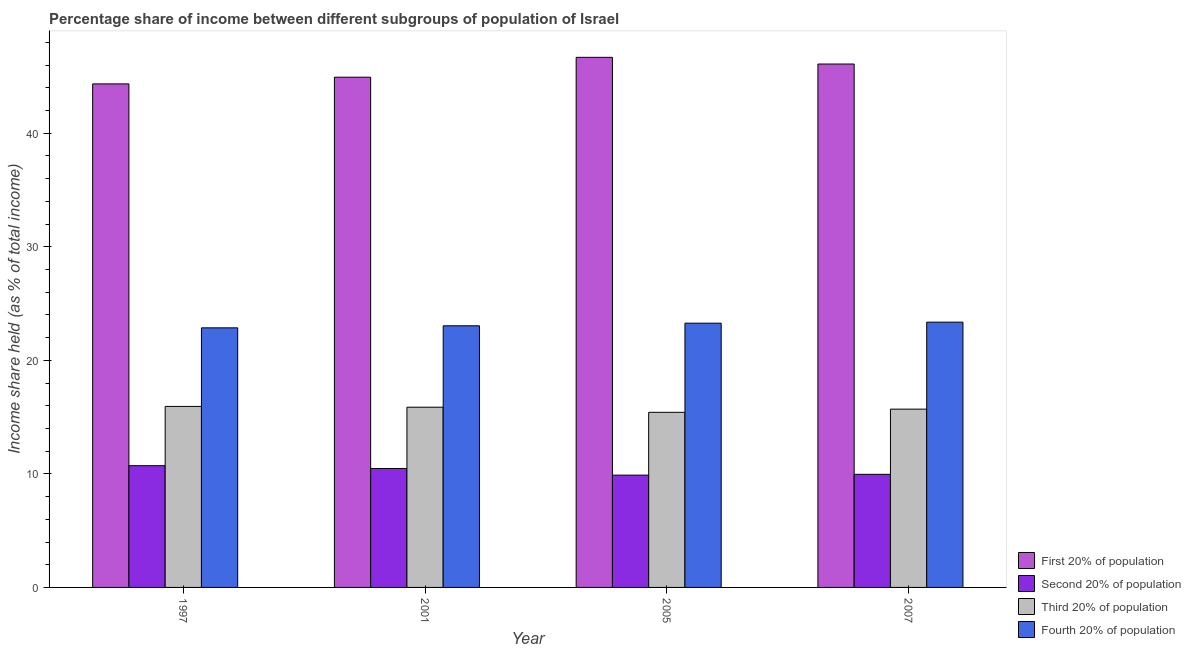How many different coloured bars are there?
Your response must be concise. 4. How many groups of bars are there?
Offer a very short reply. 4. Are the number of bars on each tick of the X-axis equal?
Provide a short and direct response. Yes. How many bars are there on the 3rd tick from the left?
Provide a short and direct response. 4. What is the label of the 3rd group of bars from the left?
Offer a very short reply. 2005. In how many cases, is the number of bars for a given year not equal to the number of legend labels?
Keep it short and to the point. 0. What is the share of the income held by third 20% of the population in 2007?
Your answer should be compact. 15.7. Across all years, what is the maximum share of the income held by third 20% of the population?
Your answer should be compact. 15.94. Across all years, what is the minimum share of the income held by fourth 20% of the population?
Offer a terse response. 22.86. In which year was the share of the income held by second 20% of the population maximum?
Keep it short and to the point. 1997. What is the total share of the income held by third 20% of the population in the graph?
Give a very brief answer. 62.93. What is the difference between the share of the income held by second 20% of the population in 1997 and that in 2005?
Provide a short and direct response. 0.83. What is the difference between the share of the income held by first 20% of the population in 2005 and the share of the income held by third 20% of the population in 2007?
Your answer should be very brief. 0.59. What is the average share of the income held by first 20% of the population per year?
Keep it short and to the point. 45.51. In the year 2007, what is the difference between the share of the income held by fourth 20% of the population and share of the income held by first 20% of the population?
Offer a terse response. 0. What is the ratio of the share of the income held by first 20% of the population in 1997 to that in 2001?
Provide a succinct answer. 0.99. Is the share of the income held by second 20% of the population in 1997 less than that in 2001?
Your response must be concise. No. Is the difference between the share of the income held by first 20% of the population in 1997 and 2001 greater than the difference between the share of the income held by fourth 20% of the population in 1997 and 2001?
Your response must be concise. No. What is the difference between the highest and the second highest share of the income held by first 20% of the population?
Offer a terse response. 0.59. What is the difference between the highest and the lowest share of the income held by first 20% of the population?
Keep it short and to the point. 2.34. Is the sum of the share of the income held by third 20% of the population in 1997 and 2007 greater than the maximum share of the income held by fourth 20% of the population across all years?
Offer a terse response. Yes. What does the 4th bar from the left in 1997 represents?
Your answer should be very brief. Fourth 20% of population. What does the 3rd bar from the right in 1997 represents?
Make the answer very short. Second 20% of population. Is it the case that in every year, the sum of the share of the income held by first 20% of the population and share of the income held by second 20% of the population is greater than the share of the income held by third 20% of the population?
Offer a terse response. Yes. What is the difference between two consecutive major ticks on the Y-axis?
Provide a short and direct response. 10. Are the values on the major ticks of Y-axis written in scientific E-notation?
Your answer should be compact. No. Does the graph contain any zero values?
Your answer should be compact. No. Where does the legend appear in the graph?
Your response must be concise. Bottom right. How are the legend labels stacked?
Provide a succinct answer. Vertical. What is the title of the graph?
Your answer should be very brief. Percentage share of income between different subgroups of population of Israel. Does "Norway" appear as one of the legend labels in the graph?
Make the answer very short. No. What is the label or title of the Y-axis?
Offer a terse response. Income share held (as % of total income). What is the Income share held (as % of total income) of First 20% of population in 1997?
Your response must be concise. 44.34. What is the Income share held (as % of total income) in Second 20% of population in 1997?
Give a very brief answer. 10.72. What is the Income share held (as % of total income) of Third 20% of population in 1997?
Your answer should be very brief. 15.94. What is the Income share held (as % of total income) in Fourth 20% of population in 1997?
Give a very brief answer. 22.86. What is the Income share held (as % of total income) in First 20% of population in 2001?
Make the answer very short. 44.93. What is the Income share held (as % of total income) of Second 20% of population in 2001?
Your response must be concise. 10.47. What is the Income share held (as % of total income) of Third 20% of population in 2001?
Give a very brief answer. 15.87. What is the Income share held (as % of total income) of Fourth 20% of population in 2001?
Provide a succinct answer. 23.04. What is the Income share held (as % of total income) of First 20% of population in 2005?
Provide a short and direct response. 46.68. What is the Income share held (as % of total income) in Second 20% of population in 2005?
Offer a terse response. 9.89. What is the Income share held (as % of total income) in Third 20% of population in 2005?
Give a very brief answer. 15.42. What is the Income share held (as % of total income) in Fourth 20% of population in 2005?
Offer a terse response. 23.27. What is the Income share held (as % of total income) in First 20% of population in 2007?
Make the answer very short. 46.09. What is the Income share held (as % of total income) of Second 20% of population in 2007?
Give a very brief answer. 9.96. What is the Income share held (as % of total income) in Third 20% of population in 2007?
Keep it short and to the point. 15.7. What is the Income share held (as % of total income) in Fourth 20% of population in 2007?
Provide a short and direct response. 23.36. Across all years, what is the maximum Income share held (as % of total income) of First 20% of population?
Your response must be concise. 46.68. Across all years, what is the maximum Income share held (as % of total income) in Second 20% of population?
Offer a terse response. 10.72. Across all years, what is the maximum Income share held (as % of total income) of Third 20% of population?
Offer a very short reply. 15.94. Across all years, what is the maximum Income share held (as % of total income) in Fourth 20% of population?
Your answer should be compact. 23.36. Across all years, what is the minimum Income share held (as % of total income) in First 20% of population?
Your response must be concise. 44.34. Across all years, what is the minimum Income share held (as % of total income) in Second 20% of population?
Ensure brevity in your answer.  9.89. Across all years, what is the minimum Income share held (as % of total income) in Third 20% of population?
Your answer should be very brief. 15.42. Across all years, what is the minimum Income share held (as % of total income) in Fourth 20% of population?
Ensure brevity in your answer.  22.86. What is the total Income share held (as % of total income) of First 20% of population in the graph?
Offer a very short reply. 182.04. What is the total Income share held (as % of total income) of Second 20% of population in the graph?
Ensure brevity in your answer.  41.04. What is the total Income share held (as % of total income) in Third 20% of population in the graph?
Keep it short and to the point. 62.93. What is the total Income share held (as % of total income) in Fourth 20% of population in the graph?
Keep it short and to the point. 92.53. What is the difference between the Income share held (as % of total income) of First 20% of population in 1997 and that in 2001?
Ensure brevity in your answer.  -0.59. What is the difference between the Income share held (as % of total income) in Third 20% of population in 1997 and that in 2001?
Your answer should be compact. 0.07. What is the difference between the Income share held (as % of total income) of Fourth 20% of population in 1997 and that in 2001?
Offer a very short reply. -0.18. What is the difference between the Income share held (as % of total income) in First 20% of population in 1997 and that in 2005?
Your answer should be compact. -2.34. What is the difference between the Income share held (as % of total income) of Second 20% of population in 1997 and that in 2005?
Your answer should be compact. 0.83. What is the difference between the Income share held (as % of total income) of Third 20% of population in 1997 and that in 2005?
Your answer should be very brief. 0.52. What is the difference between the Income share held (as % of total income) of Fourth 20% of population in 1997 and that in 2005?
Keep it short and to the point. -0.41. What is the difference between the Income share held (as % of total income) of First 20% of population in 1997 and that in 2007?
Ensure brevity in your answer.  -1.75. What is the difference between the Income share held (as % of total income) of Second 20% of population in 1997 and that in 2007?
Your answer should be very brief. 0.76. What is the difference between the Income share held (as % of total income) in Third 20% of population in 1997 and that in 2007?
Provide a succinct answer. 0.24. What is the difference between the Income share held (as % of total income) of First 20% of population in 2001 and that in 2005?
Provide a short and direct response. -1.75. What is the difference between the Income share held (as % of total income) of Second 20% of population in 2001 and that in 2005?
Provide a short and direct response. 0.58. What is the difference between the Income share held (as % of total income) in Third 20% of population in 2001 and that in 2005?
Provide a succinct answer. 0.45. What is the difference between the Income share held (as % of total income) in Fourth 20% of population in 2001 and that in 2005?
Your response must be concise. -0.23. What is the difference between the Income share held (as % of total income) of First 20% of population in 2001 and that in 2007?
Keep it short and to the point. -1.16. What is the difference between the Income share held (as % of total income) in Second 20% of population in 2001 and that in 2007?
Your answer should be compact. 0.51. What is the difference between the Income share held (as % of total income) of Third 20% of population in 2001 and that in 2007?
Make the answer very short. 0.17. What is the difference between the Income share held (as % of total income) in Fourth 20% of population in 2001 and that in 2007?
Your answer should be compact. -0.32. What is the difference between the Income share held (as % of total income) in First 20% of population in 2005 and that in 2007?
Your answer should be compact. 0.59. What is the difference between the Income share held (as % of total income) in Second 20% of population in 2005 and that in 2007?
Ensure brevity in your answer.  -0.07. What is the difference between the Income share held (as % of total income) of Third 20% of population in 2005 and that in 2007?
Your answer should be compact. -0.28. What is the difference between the Income share held (as % of total income) in Fourth 20% of population in 2005 and that in 2007?
Your answer should be very brief. -0.09. What is the difference between the Income share held (as % of total income) of First 20% of population in 1997 and the Income share held (as % of total income) of Second 20% of population in 2001?
Your response must be concise. 33.87. What is the difference between the Income share held (as % of total income) of First 20% of population in 1997 and the Income share held (as % of total income) of Third 20% of population in 2001?
Offer a very short reply. 28.47. What is the difference between the Income share held (as % of total income) of First 20% of population in 1997 and the Income share held (as % of total income) of Fourth 20% of population in 2001?
Offer a very short reply. 21.3. What is the difference between the Income share held (as % of total income) of Second 20% of population in 1997 and the Income share held (as % of total income) of Third 20% of population in 2001?
Offer a terse response. -5.15. What is the difference between the Income share held (as % of total income) in Second 20% of population in 1997 and the Income share held (as % of total income) in Fourth 20% of population in 2001?
Your response must be concise. -12.32. What is the difference between the Income share held (as % of total income) of First 20% of population in 1997 and the Income share held (as % of total income) of Second 20% of population in 2005?
Give a very brief answer. 34.45. What is the difference between the Income share held (as % of total income) in First 20% of population in 1997 and the Income share held (as % of total income) in Third 20% of population in 2005?
Ensure brevity in your answer.  28.92. What is the difference between the Income share held (as % of total income) in First 20% of population in 1997 and the Income share held (as % of total income) in Fourth 20% of population in 2005?
Make the answer very short. 21.07. What is the difference between the Income share held (as % of total income) in Second 20% of population in 1997 and the Income share held (as % of total income) in Third 20% of population in 2005?
Your answer should be compact. -4.7. What is the difference between the Income share held (as % of total income) in Second 20% of population in 1997 and the Income share held (as % of total income) in Fourth 20% of population in 2005?
Provide a short and direct response. -12.55. What is the difference between the Income share held (as % of total income) in Third 20% of population in 1997 and the Income share held (as % of total income) in Fourth 20% of population in 2005?
Keep it short and to the point. -7.33. What is the difference between the Income share held (as % of total income) in First 20% of population in 1997 and the Income share held (as % of total income) in Second 20% of population in 2007?
Keep it short and to the point. 34.38. What is the difference between the Income share held (as % of total income) in First 20% of population in 1997 and the Income share held (as % of total income) in Third 20% of population in 2007?
Provide a short and direct response. 28.64. What is the difference between the Income share held (as % of total income) of First 20% of population in 1997 and the Income share held (as % of total income) of Fourth 20% of population in 2007?
Provide a short and direct response. 20.98. What is the difference between the Income share held (as % of total income) in Second 20% of population in 1997 and the Income share held (as % of total income) in Third 20% of population in 2007?
Offer a very short reply. -4.98. What is the difference between the Income share held (as % of total income) of Second 20% of population in 1997 and the Income share held (as % of total income) of Fourth 20% of population in 2007?
Keep it short and to the point. -12.64. What is the difference between the Income share held (as % of total income) of Third 20% of population in 1997 and the Income share held (as % of total income) of Fourth 20% of population in 2007?
Provide a succinct answer. -7.42. What is the difference between the Income share held (as % of total income) in First 20% of population in 2001 and the Income share held (as % of total income) in Second 20% of population in 2005?
Offer a terse response. 35.04. What is the difference between the Income share held (as % of total income) of First 20% of population in 2001 and the Income share held (as % of total income) of Third 20% of population in 2005?
Your answer should be compact. 29.51. What is the difference between the Income share held (as % of total income) of First 20% of population in 2001 and the Income share held (as % of total income) of Fourth 20% of population in 2005?
Provide a short and direct response. 21.66. What is the difference between the Income share held (as % of total income) of Second 20% of population in 2001 and the Income share held (as % of total income) of Third 20% of population in 2005?
Ensure brevity in your answer.  -4.95. What is the difference between the Income share held (as % of total income) of First 20% of population in 2001 and the Income share held (as % of total income) of Second 20% of population in 2007?
Your answer should be compact. 34.97. What is the difference between the Income share held (as % of total income) in First 20% of population in 2001 and the Income share held (as % of total income) in Third 20% of population in 2007?
Provide a succinct answer. 29.23. What is the difference between the Income share held (as % of total income) in First 20% of population in 2001 and the Income share held (as % of total income) in Fourth 20% of population in 2007?
Make the answer very short. 21.57. What is the difference between the Income share held (as % of total income) of Second 20% of population in 2001 and the Income share held (as % of total income) of Third 20% of population in 2007?
Your answer should be very brief. -5.23. What is the difference between the Income share held (as % of total income) of Second 20% of population in 2001 and the Income share held (as % of total income) of Fourth 20% of population in 2007?
Make the answer very short. -12.89. What is the difference between the Income share held (as % of total income) in Third 20% of population in 2001 and the Income share held (as % of total income) in Fourth 20% of population in 2007?
Provide a succinct answer. -7.49. What is the difference between the Income share held (as % of total income) in First 20% of population in 2005 and the Income share held (as % of total income) in Second 20% of population in 2007?
Your answer should be very brief. 36.72. What is the difference between the Income share held (as % of total income) of First 20% of population in 2005 and the Income share held (as % of total income) of Third 20% of population in 2007?
Ensure brevity in your answer.  30.98. What is the difference between the Income share held (as % of total income) in First 20% of population in 2005 and the Income share held (as % of total income) in Fourth 20% of population in 2007?
Provide a succinct answer. 23.32. What is the difference between the Income share held (as % of total income) of Second 20% of population in 2005 and the Income share held (as % of total income) of Third 20% of population in 2007?
Keep it short and to the point. -5.81. What is the difference between the Income share held (as % of total income) of Second 20% of population in 2005 and the Income share held (as % of total income) of Fourth 20% of population in 2007?
Offer a very short reply. -13.47. What is the difference between the Income share held (as % of total income) of Third 20% of population in 2005 and the Income share held (as % of total income) of Fourth 20% of population in 2007?
Your answer should be very brief. -7.94. What is the average Income share held (as % of total income) in First 20% of population per year?
Make the answer very short. 45.51. What is the average Income share held (as % of total income) of Second 20% of population per year?
Keep it short and to the point. 10.26. What is the average Income share held (as % of total income) of Third 20% of population per year?
Your response must be concise. 15.73. What is the average Income share held (as % of total income) in Fourth 20% of population per year?
Make the answer very short. 23.13. In the year 1997, what is the difference between the Income share held (as % of total income) of First 20% of population and Income share held (as % of total income) of Second 20% of population?
Your response must be concise. 33.62. In the year 1997, what is the difference between the Income share held (as % of total income) in First 20% of population and Income share held (as % of total income) in Third 20% of population?
Offer a terse response. 28.4. In the year 1997, what is the difference between the Income share held (as % of total income) of First 20% of population and Income share held (as % of total income) of Fourth 20% of population?
Ensure brevity in your answer.  21.48. In the year 1997, what is the difference between the Income share held (as % of total income) of Second 20% of population and Income share held (as % of total income) of Third 20% of population?
Your answer should be very brief. -5.22. In the year 1997, what is the difference between the Income share held (as % of total income) in Second 20% of population and Income share held (as % of total income) in Fourth 20% of population?
Give a very brief answer. -12.14. In the year 1997, what is the difference between the Income share held (as % of total income) in Third 20% of population and Income share held (as % of total income) in Fourth 20% of population?
Ensure brevity in your answer.  -6.92. In the year 2001, what is the difference between the Income share held (as % of total income) of First 20% of population and Income share held (as % of total income) of Second 20% of population?
Your answer should be compact. 34.46. In the year 2001, what is the difference between the Income share held (as % of total income) of First 20% of population and Income share held (as % of total income) of Third 20% of population?
Offer a very short reply. 29.06. In the year 2001, what is the difference between the Income share held (as % of total income) in First 20% of population and Income share held (as % of total income) in Fourth 20% of population?
Offer a very short reply. 21.89. In the year 2001, what is the difference between the Income share held (as % of total income) in Second 20% of population and Income share held (as % of total income) in Fourth 20% of population?
Your answer should be compact. -12.57. In the year 2001, what is the difference between the Income share held (as % of total income) of Third 20% of population and Income share held (as % of total income) of Fourth 20% of population?
Your answer should be very brief. -7.17. In the year 2005, what is the difference between the Income share held (as % of total income) of First 20% of population and Income share held (as % of total income) of Second 20% of population?
Your response must be concise. 36.79. In the year 2005, what is the difference between the Income share held (as % of total income) of First 20% of population and Income share held (as % of total income) of Third 20% of population?
Provide a succinct answer. 31.26. In the year 2005, what is the difference between the Income share held (as % of total income) in First 20% of population and Income share held (as % of total income) in Fourth 20% of population?
Keep it short and to the point. 23.41. In the year 2005, what is the difference between the Income share held (as % of total income) in Second 20% of population and Income share held (as % of total income) in Third 20% of population?
Give a very brief answer. -5.53. In the year 2005, what is the difference between the Income share held (as % of total income) in Second 20% of population and Income share held (as % of total income) in Fourth 20% of population?
Keep it short and to the point. -13.38. In the year 2005, what is the difference between the Income share held (as % of total income) of Third 20% of population and Income share held (as % of total income) of Fourth 20% of population?
Keep it short and to the point. -7.85. In the year 2007, what is the difference between the Income share held (as % of total income) in First 20% of population and Income share held (as % of total income) in Second 20% of population?
Offer a terse response. 36.13. In the year 2007, what is the difference between the Income share held (as % of total income) of First 20% of population and Income share held (as % of total income) of Third 20% of population?
Your answer should be compact. 30.39. In the year 2007, what is the difference between the Income share held (as % of total income) in First 20% of population and Income share held (as % of total income) in Fourth 20% of population?
Make the answer very short. 22.73. In the year 2007, what is the difference between the Income share held (as % of total income) of Second 20% of population and Income share held (as % of total income) of Third 20% of population?
Give a very brief answer. -5.74. In the year 2007, what is the difference between the Income share held (as % of total income) of Third 20% of population and Income share held (as % of total income) of Fourth 20% of population?
Ensure brevity in your answer.  -7.66. What is the ratio of the Income share held (as % of total income) in First 20% of population in 1997 to that in 2001?
Make the answer very short. 0.99. What is the ratio of the Income share held (as % of total income) of Second 20% of population in 1997 to that in 2001?
Keep it short and to the point. 1.02. What is the ratio of the Income share held (as % of total income) of First 20% of population in 1997 to that in 2005?
Offer a terse response. 0.95. What is the ratio of the Income share held (as % of total income) in Second 20% of population in 1997 to that in 2005?
Make the answer very short. 1.08. What is the ratio of the Income share held (as % of total income) of Third 20% of population in 1997 to that in 2005?
Ensure brevity in your answer.  1.03. What is the ratio of the Income share held (as % of total income) of Fourth 20% of population in 1997 to that in 2005?
Keep it short and to the point. 0.98. What is the ratio of the Income share held (as % of total income) of Second 20% of population in 1997 to that in 2007?
Offer a terse response. 1.08. What is the ratio of the Income share held (as % of total income) in Third 20% of population in 1997 to that in 2007?
Your answer should be very brief. 1.02. What is the ratio of the Income share held (as % of total income) of Fourth 20% of population in 1997 to that in 2007?
Ensure brevity in your answer.  0.98. What is the ratio of the Income share held (as % of total income) of First 20% of population in 2001 to that in 2005?
Your answer should be very brief. 0.96. What is the ratio of the Income share held (as % of total income) of Second 20% of population in 2001 to that in 2005?
Your answer should be very brief. 1.06. What is the ratio of the Income share held (as % of total income) in Third 20% of population in 2001 to that in 2005?
Provide a short and direct response. 1.03. What is the ratio of the Income share held (as % of total income) of First 20% of population in 2001 to that in 2007?
Provide a short and direct response. 0.97. What is the ratio of the Income share held (as % of total income) in Second 20% of population in 2001 to that in 2007?
Provide a succinct answer. 1.05. What is the ratio of the Income share held (as % of total income) in Third 20% of population in 2001 to that in 2007?
Provide a succinct answer. 1.01. What is the ratio of the Income share held (as % of total income) of Fourth 20% of population in 2001 to that in 2007?
Make the answer very short. 0.99. What is the ratio of the Income share held (as % of total income) in First 20% of population in 2005 to that in 2007?
Ensure brevity in your answer.  1.01. What is the ratio of the Income share held (as % of total income) in Second 20% of population in 2005 to that in 2007?
Ensure brevity in your answer.  0.99. What is the ratio of the Income share held (as % of total income) in Third 20% of population in 2005 to that in 2007?
Your answer should be compact. 0.98. What is the ratio of the Income share held (as % of total income) of Fourth 20% of population in 2005 to that in 2007?
Your answer should be compact. 1. What is the difference between the highest and the second highest Income share held (as % of total income) in First 20% of population?
Provide a short and direct response. 0.59. What is the difference between the highest and the second highest Income share held (as % of total income) of Second 20% of population?
Provide a short and direct response. 0.25. What is the difference between the highest and the second highest Income share held (as % of total income) of Third 20% of population?
Your answer should be compact. 0.07. What is the difference between the highest and the second highest Income share held (as % of total income) of Fourth 20% of population?
Your answer should be compact. 0.09. What is the difference between the highest and the lowest Income share held (as % of total income) of First 20% of population?
Give a very brief answer. 2.34. What is the difference between the highest and the lowest Income share held (as % of total income) of Second 20% of population?
Provide a short and direct response. 0.83. What is the difference between the highest and the lowest Income share held (as % of total income) of Third 20% of population?
Your answer should be compact. 0.52. 